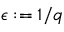Convert formula to latex. <formula><loc_0><loc_0><loc_500><loc_500>\epsilon \colon = 1 / q</formula> 